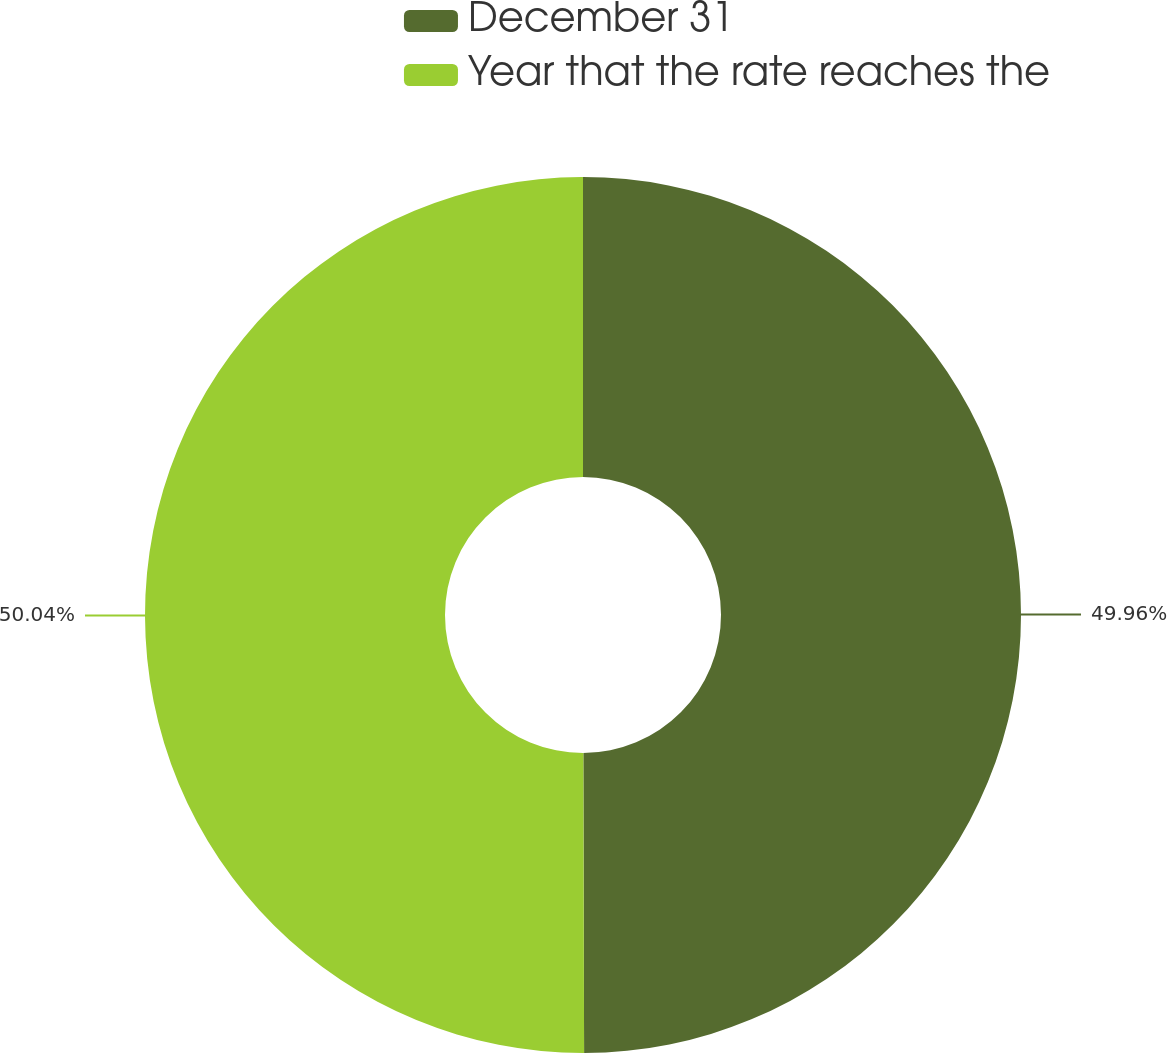<chart> <loc_0><loc_0><loc_500><loc_500><pie_chart><fcel>December 31<fcel>Year that the rate reaches the<nl><fcel>49.96%<fcel>50.04%<nl></chart> 